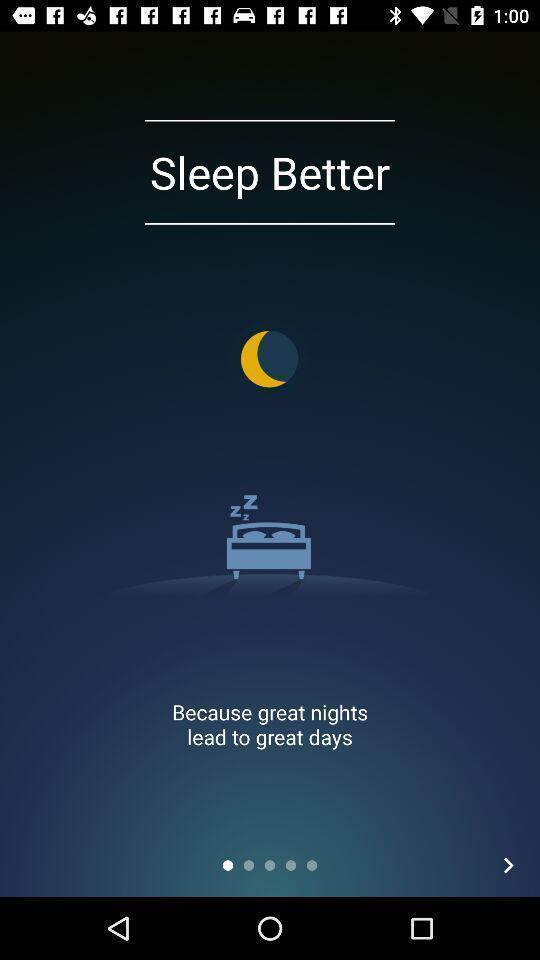Please provide a description for this image. Welcome page. 